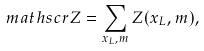Convert formula to latex. <formula><loc_0><loc_0><loc_500><loc_500>\ m a t h s c r { Z } = \sum _ { x _ { L } , m } Z ( x _ { L } , m ) ,</formula> 